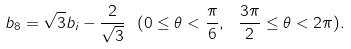<formula> <loc_0><loc_0><loc_500><loc_500>b _ { 8 } = \sqrt { 3 } b _ { i } - \frac { 2 } { \sqrt { 3 } } \ ( 0 \leq \theta < \frac { \pi } { 6 } , \ \frac { 3 \pi } { 2 } \leq \theta < 2 \pi ) .</formula> 